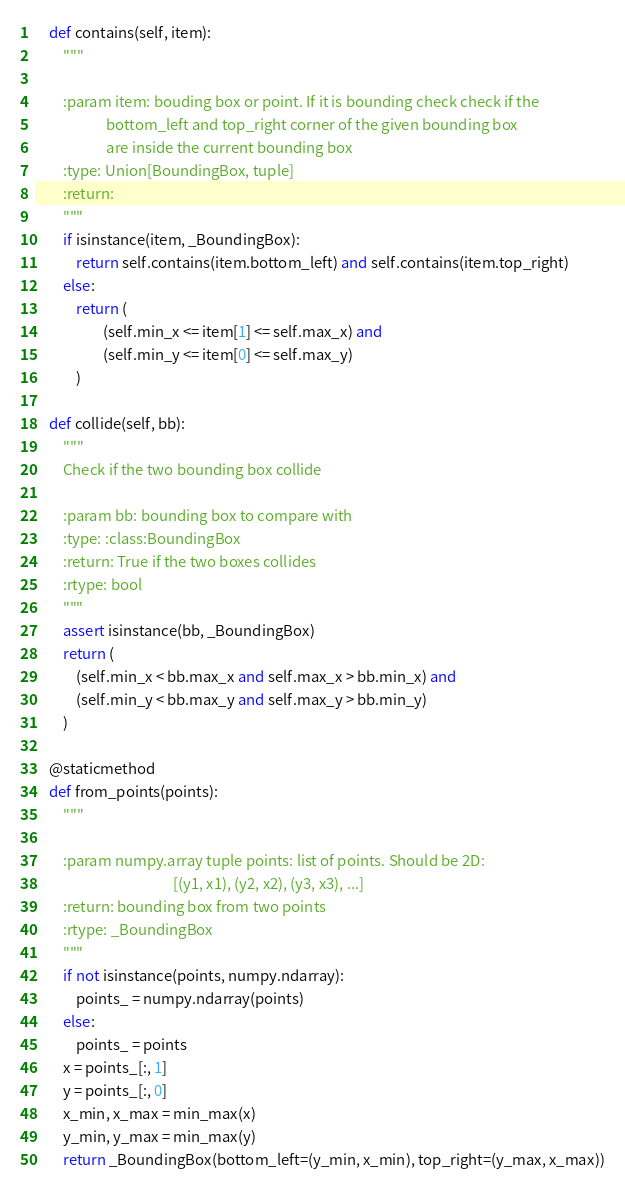<code> <loc_0><loc_0><loc_500><loc_500><_Python_>
    def contains(self, item):
        """

        :param item: bouding box or point. If it is bounding check check if the
                     bottom_left and top_right corner of the given bounding box
                     are inside the current bounding box
        :type: Union[BoundingBox, tuple]
        :return:
        """
        if isinstance(item, _BoundingBox):
            return self.contains(item.bottom_left) and self.contains(item.top_right)
        else:
            return (
                    (self.min_x <= item[1] <= self.max_x) and
                    (self.min_y <= item[0] <= self.max_y)
            )

    def collide(self, bb):
        """
        Check if the two bounding box collide

        :param bb: bounding box to compare with
        :type: :class:BoundingBox
        :return: True if the two boxes collides
        :rtype: bool
        """
        assert isinstance(bb, _BoundingBox)
        return (
            (self.min_x < bb.max_x and self.max_x > bb.min_x) and
            (self.min_y < bb.max_y and self.max_y > bb.min_y)
        )

    @staticmethod
    def from_points(points):
        """

        :param numpy.array tuple points: list of points. Should be 2D:
                                         [(y1, x1), (y2, x2), (y3, x3), ...]
        :return: bounding box from two points
        :rtype: _BoundingBox
        """
        if not isinstance(points, numpy.ndarray):
            points_ = numpy.ndarray(points)
        else:
            points_ = points
        x = points_[:, 1]
        y = points_[:, 0]
        x_min, x_max = min_max(x)
        y_min, y_max = min_max(y)
        return _BoundingBox(bottom_left=(y_min, x_min), top_right=(y_max, x_max))
</code> 